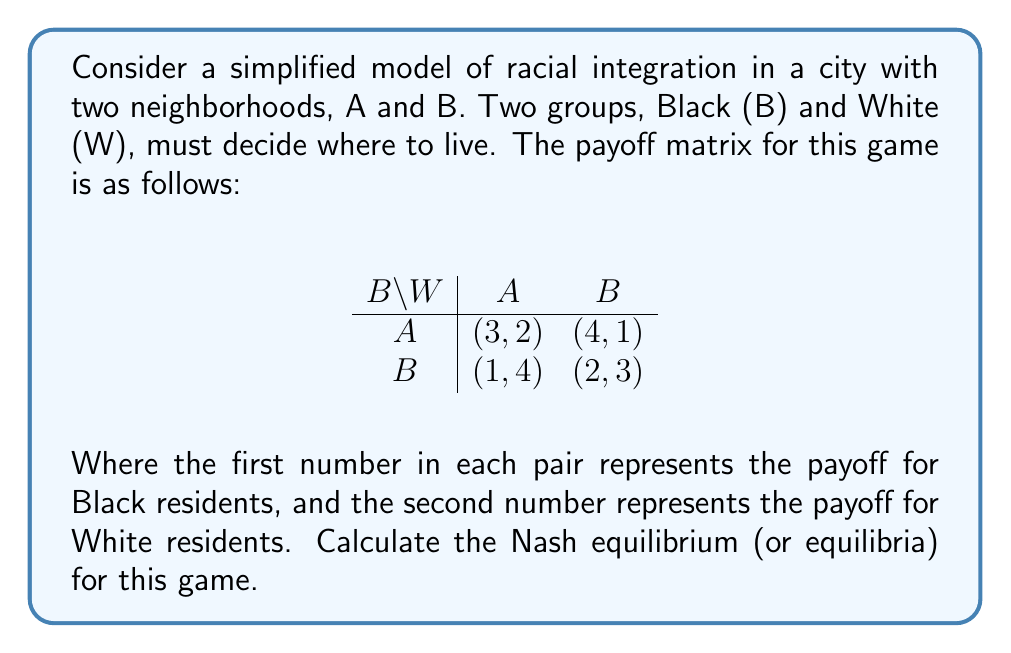Teach me how to tackle this problem. To find the Nash equilibrium, we need to determine the best response for each player given the other player's strategy.

1. For Black residents:
   - If White chooses A: Black's best response is A (3 > 1)
   - If White chooses B: Black's best response is A (4 > 2)

2. For White residents:
   - If Black chooses A: White's best response is B (4 > 2)
   - If Black chooses B: White's best response is A (4 > 3)

We can see that there is no pure strategy Nash equilibrium because there's no cell where both players are playing their best response to each other's strategies.

Therefore, we need to look for a mixed strategy Nash equilibrium.

Let $p$ be the probability that Black chooses A, and $q$ be the probability that White chooses A.

For Black to be indifferent between A and B:

$$3q + 4(1-q) = 1q + 2(1-q)$$
$$3q + 4 - 4q = q + 2 - 2q$$
$$-q + 4 = -q + 2$$
$$4 = 2$$

This equation has no solution, which means Black will always prefer a pure strategy (in this case, always choose A).

For White to be indifferent between A and B:

$$2p + 1(1-p) = 4p + 3(1-p)$$
$$2p + 1 - p = 4p + 3 - 3p$$
$$p + 1 = p + 3$$
$$1 = 3$$

This equation also has no solution, which means White will always prefer a pure strategy (in this case, always choose B).

Therefore, the unique Nash equilibrium for this game is (A, B), where Black always chooses neighborhood A and White always chooses neighborhood B.
Answer: The unique Nash equilibrium is (A, B), where Black residents always choose neighborhood A and White residents always choose neighborhood B. 